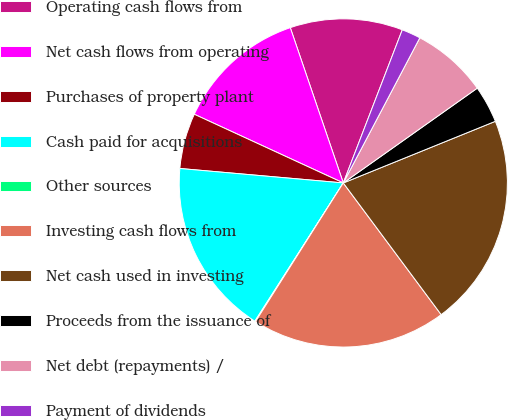Convert chart to OTSL. <chart><loc_0><loc_0><loc_500><loc_500><pie_chart><fcel>Operating cash flows from<fcel>Net cash flows from operating<fcel>Purchases of property plant<fcel>Cash paid for acquisitions<fcel>Other sources<fcel>Investing cash flows from<fcel>Net cash used in investing<fcel>Proceeds from the issuance of<fcel>Net debt (repayments) /<fcel>Payment of dividends<nl><fcel>11.09%<fcel>12.89%<fcel>5.47%<fcel>17.35%<fcel>0.07%<fcel>19.16%<fcel>20.96%<fcel>3.67%<fcel>7.48%<fcel>1.87%<nl></chart> 